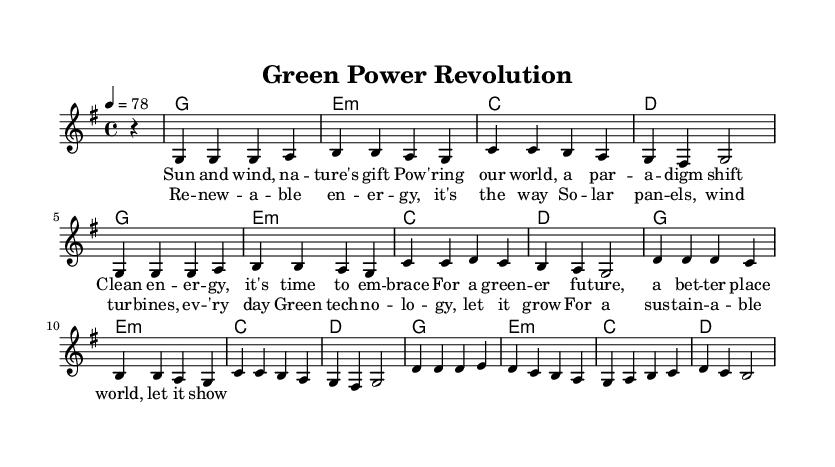What is the key signature of this music? The key signature is G major, which has one sharp (F#).
Answer: G major What is the time signature of this music? The time signature is 4/4, indicating four beats per measure.
Answer: 4/4 What is the tempo marking for this piece? The tempo marking indicates a speed of 78 beats per minute.
Answer: 78 How many verses are present in the lyrics? There is one verse followed by a chorus, totaling two distinct sections in the lyrics.
Answer: 1 verse What type of energy sources are mentioned in the chorus? The chorus mentions solar panels and wind turbines as renewable energy sources.
Answer: Solar panels, wind turbines What is the primary theme of the song? The primary theme focuses on advocating for renewable energy and sustainable practices, promoting a green future.
Answer: Renewable energy and sustainability What genre does this song belong to? This song belongs to the reggae genre, characterized by its emphasis on rhythmic style and socially conscious lyrics.
Answer: Reggae 